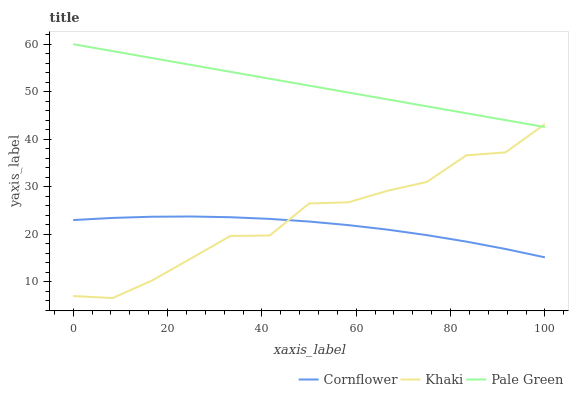Does Cornflower have the minimum area under the curve?
Answer yes or no. Yes. Does Pale Green have the maximum area under the curve?
Answer yes or no. Yes. Does Khaki have the minimum area under the curve?
Answer yes or no. No. Does Khaki have the maximum area under the curve?
Answer yes or no. No. Is Pale Green the smoothest?
Answer yes or no. Yes. Is Khaki the roughest?
Answer yes or no. Yes. Is Khaki the smoothest?
Answer yes or no. No. Is Pale Green the roughest?
Answer yes or no. No. Does Khaki have the lowest value?
Answer yes or no. Yes. Does Pale Green have the lowest value?
Answer yes or no. No. Does Pale Green have the highest value?
Answer yes or no. Yes. Does Khaki have the highest value?
Answer yes or no. No. Is Cornflower less than Pale Green?
Answer yes or no. Yes. Is Pale Green greater than Cornflower?
Answer yes or no. Yes. Does Cornflower intersect Khaki?
Answer yes or no. Yes. Is Cornflower less than Khaki?
Answer yes or no. No. Is Cornflower greater than Khaki?
Answer yes or no. No. Does Cornflower intersect Pale Green?
Answer yes or no. No. 